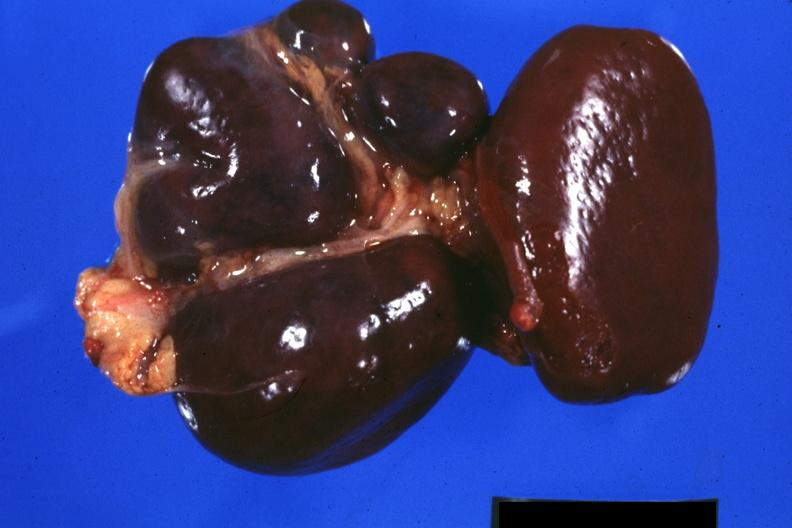what is present?
Answer the question using a single word or phrase. Spleen 